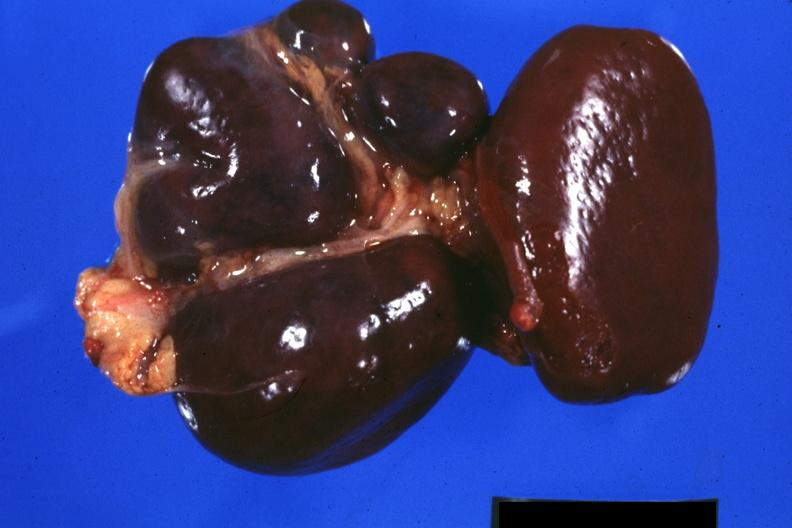what is present?
Answer the question using a single word or phrase. Spleen 